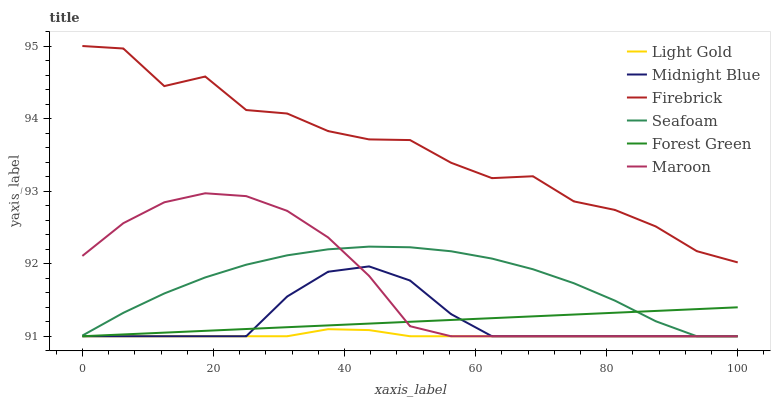Does Light Gold have the minimum area under the curve?
Answer yes or no. Yes. Does Firebrick have the maximum area under the curve?
Answer yes or no. Yes. Does Seafoam have the minimum area under the curve?
Answer yes or no. No. Does Seafoam have the maximum area under the curve?
Answer yes or no. No. Is Forest Green the smoothest?
Answer yes or no. Yes. Is Firebrick the roughest?
Answer yes or no. Yes. Is Seafoam the smoothest?
Answer yes or no. No. Is Seafoam the roughest?
Answer yes or no. No. Does Midnight Blue have the lowest value?
Answer yes or no. Yes. Does Firebrick have the lowest value?
Answer yes or no. No. Does Firebrick have the highest value?
Answer yes or no. Yes. Does Seafoam have the highest value?
Answer yes or no. No. Is Seafoam less than Firebrick?
Answer yes or no. Yes. Is Firebrick greater than Light Gold?
Answer yes or no. Yes. Does Forest Green intersect Maroon?
Answer yes or no. Yes. Is Forest Green less than Maroon?
Answer yes or no. No. Is Forest Green greater than Maroon?
Answer yes or no. No. Does Seafoam intersect Firebrick?
Answer yes or no. No. 